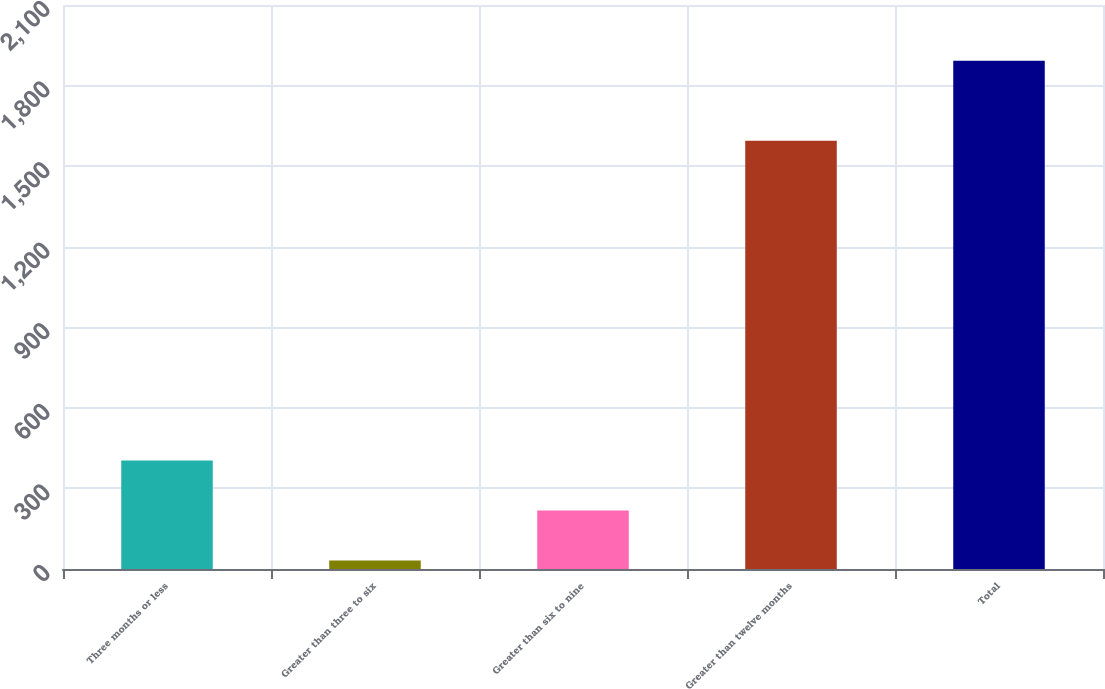<chart> <loc_0><loc_0><loc_500><loc_500><bar_chart><fcel>Three months or less<fcel>Greater than three to six<fcel>Greater than six to nine<fcel>Greater than twelve months<fcel>Total<nl><fcel>404<fcel>32<fcel>218<fcel>1595<fcel>1892<nl></chart> 